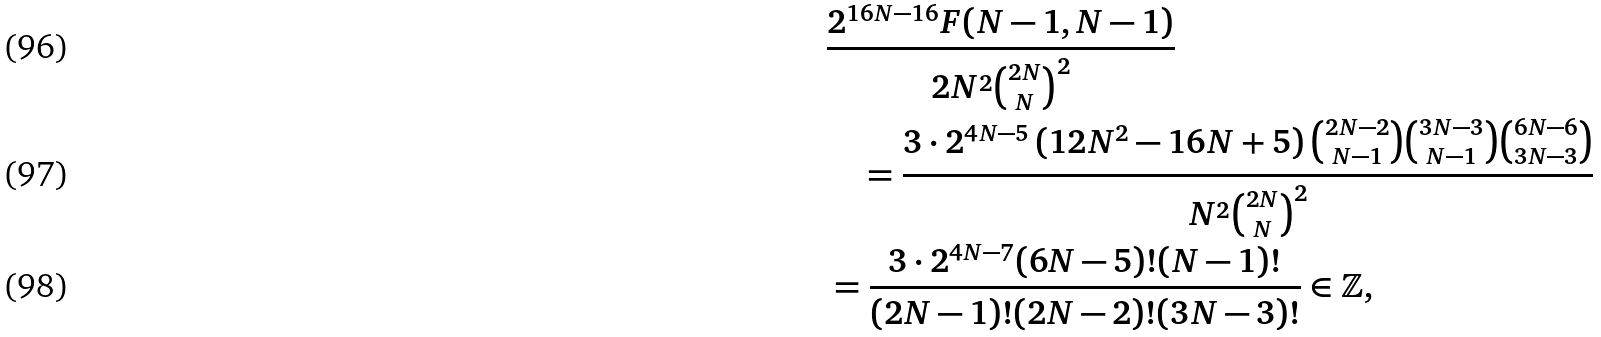<formula> <loc_0><loc_0><loc_500><loc_500>& \frac { 2 ^ { 1 6 N - 1 6 } F ( N - 1 , N - 1 ) } { 2 N ^ { 2 } \binom { 2 N } { N } ^ { 2 } } \\ & \quad = \frac { 3 \cdot 2 ^ { 4 N - 5 } \left ( 1 2 N ^ { 2 } - 1 6 N + 5 \right ) \binom { 2 N - 2 } { N - 1 } \binom { 3 N - 3 } { N - 1 } \binom { 6 N - 6 } { 3 N - 3 } } { N ^ { 2 } \binom { 2 N } { N } ^ { 2 } } \\ & = \frac { 3 \cdot 2 ^ { 4 N - 7 } ( 6 N - 5 ) ! ( N - 1 ) ! } { ( 2 N - 1 ) ! ( 2 N - 2 ) ! ( 3 N - 3 ) ! } \in \mathbb { Z } ,</formula> 